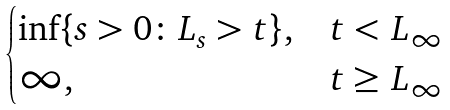Convert formula to latex. <formula><loc_0><loc_0><loc_500><loc_500>\begin{cases} \inf \{ s > 0 \colon L _ { s } > t \} , & t < L _ { \infty } \\ \infty , & t \geq L _ { \infty } \end{cases}</formula> 